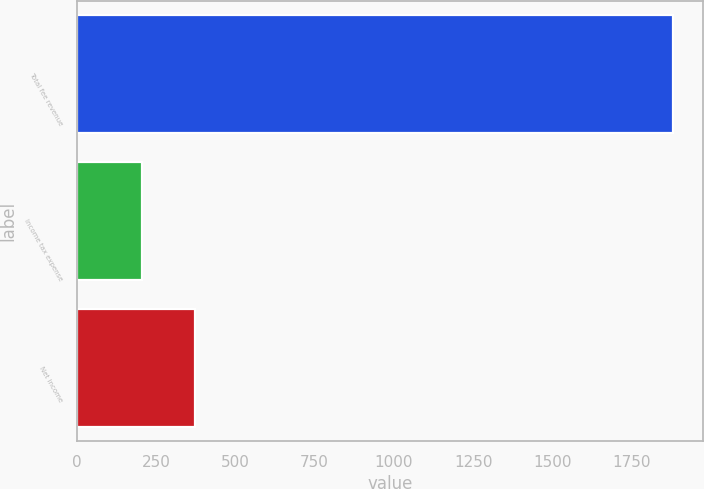<chart> <loc_0><loc_0><loc_500><loc_500><bar_chart><fcel>Total fee revenue<fcel>Income tax expense<fcel>Net income<nl><fcel>1881<fcel>205<fcel>372.6<nl></chart> 